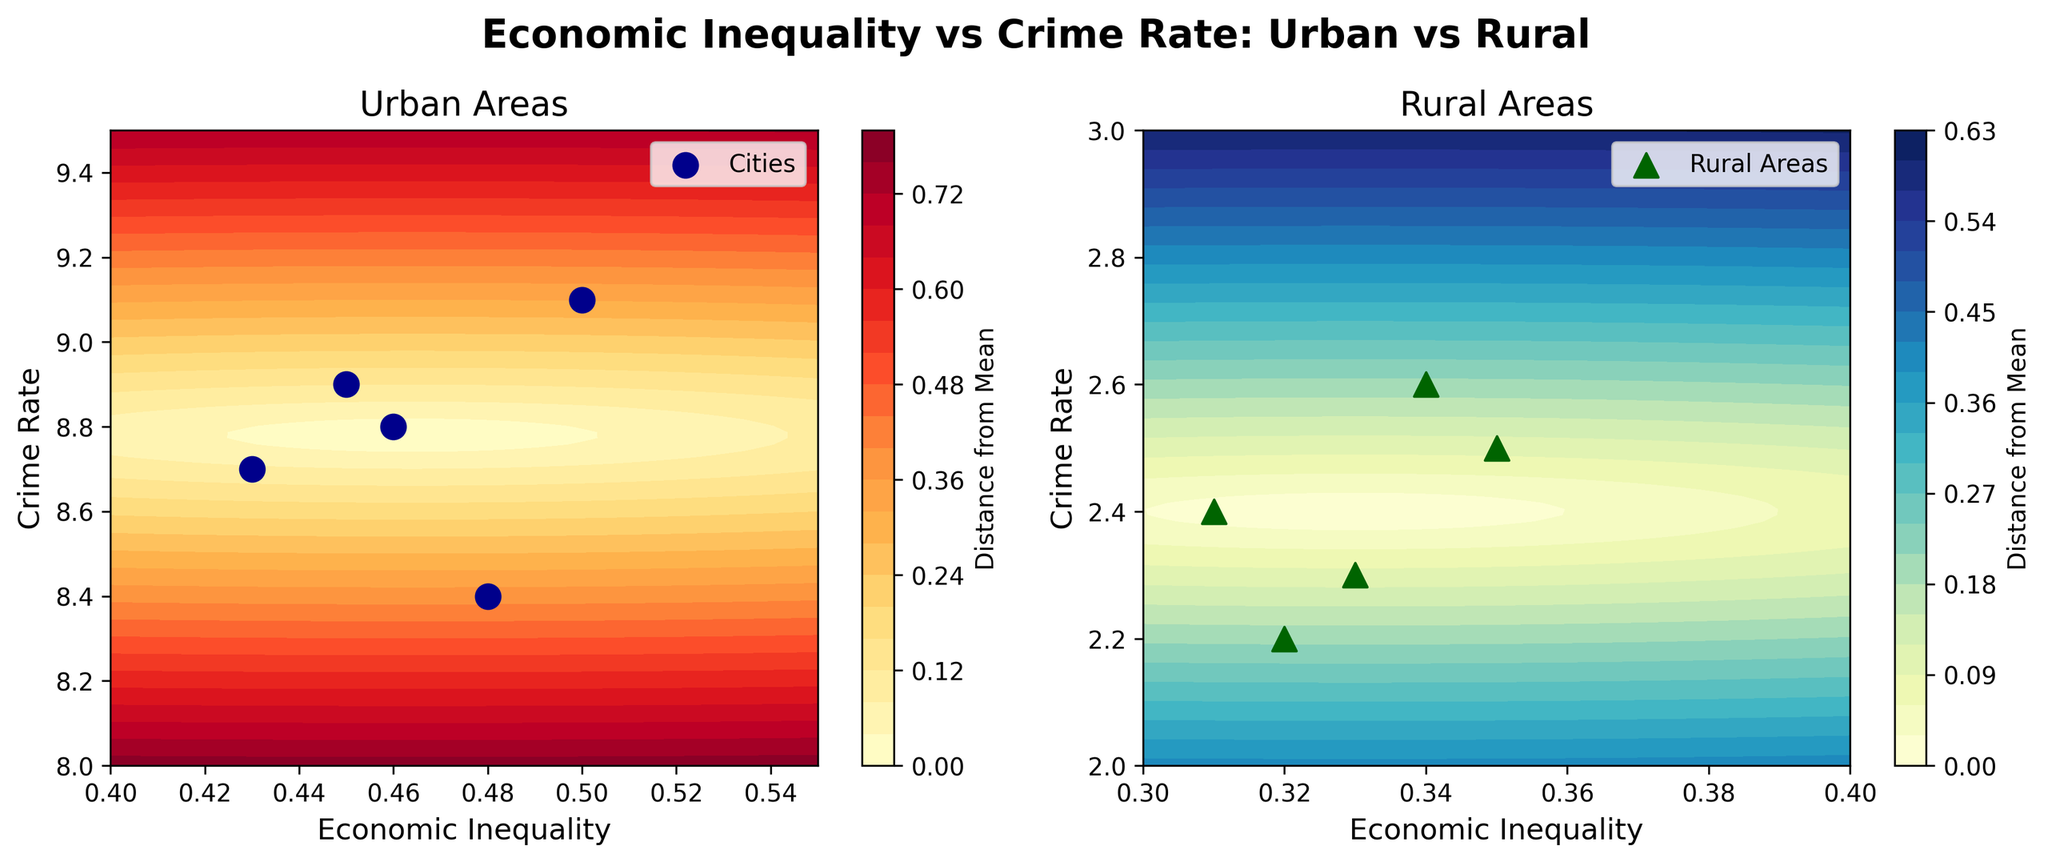How many urban areas are represented in the figure? By looking at the subplot for urban areas, we can count the number of markers representing different urban areas.
Answer: 5 What is the range of economic inequality shown for rural areas? The x-axis in the subplot for rural areas shows the range of economic inequality. By looking closely, we can see it ranges from 0.3 to 0.4.
Answer: 0.3 to 0.4 Compare the average crime rate between urban and rural areas. In the subplots, the color intensity (distance from the mean) varies. Urban areas hover around a higher range on the y-axis compared to rural areas, where the crime rate is significantly lower.
Answer: Urban > Rural Which area has the highest crime rate, and what is that rate? The highest crime rate can be identified by checking the maximum value on the crime rate axis in both subplots. From the urban subplot, Chicago has the highest crime rate.
Answer: 9.1 What is the general trend between economic inequality and crime rate in urban areas? By considering the contour lines and the scatter points in the urban subplot, it appears there is a positive correlation between economic inequality and crime rate in urban areas.
Answer: Positive correlation Which contour plot has a steeper gradient, indicating a stronger change in distance from the mean? By comparing the contour lines' spacing in both subplots, the urban subplot has a steeper gradient, indicating a stronger change in distance from the mean.
Answer: Urban Identify the data point in the rural areas with the lowest economic inequality. By observing the scatter plot in the rural subplot, we can see the lowest economic inequality is for Wyoming.
Answer: Wyoming What does the color bar represent in both subplots? The color bar in both subplots represents the distance from the mean economic inequality and crime rate values. Darker colors indicate a larger distance from these mean values.
Answer: Distance from the Mean Compare the spread of crime rates in urban versus rural areas. In urban areas, crime rates vary from about 8.4 to 9.1, while in rural areas, they range from 2.2 to 2.6. This shows that crime rates in urban areas have a wider spread.
Answer: Urban spread is wider What can be inferred about economic inequality's impact on crime rate in rural areas? By looking at the contour plot and scatter points in the rural subplot, it is observed that there is a minimal variation in crime rates despite changes in economic inequality, suggesting a weaker correlation.
Answer: Weaker correlation 